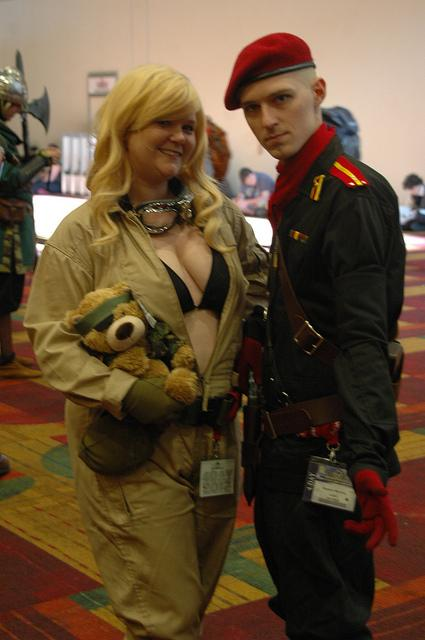What clothes are the people wearing? Please explain your reasoning. costume. The people are dressed up for halloween. 